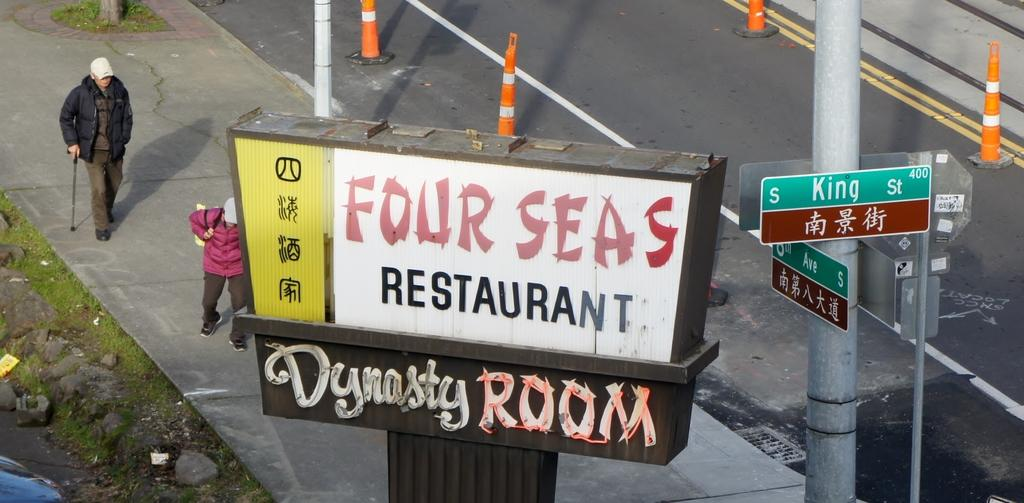<image>
Relay a brief, clear account of the picture shown. Pedestrians walk below a sign for the Four Seas restaurant. 